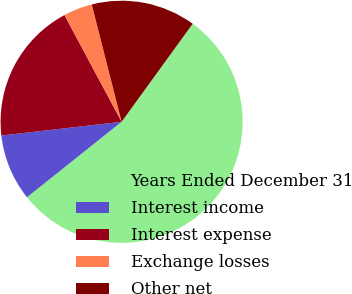<chart> <loc_0><loc_0><loc_500><loc_500><pie_chart><fcel>Years Ended December 31<fcel>Interest income<fcel>Interest expense<fcel>Exchange losses<fcel>Other net<nl><fcel>54.3%<fcel>8.9%<fcel>18.99%<fcel>3.86%<fcel>13.95%<nl></chart> 